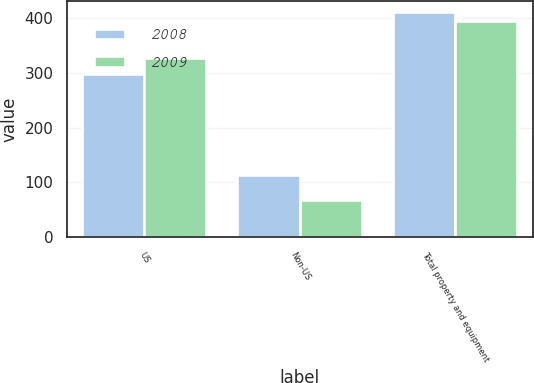<chart> <loc_0><loc_0><loc_500><loc_500><stacked_bar_chart><ecel><fcel>US<fcel>Non-US<fcel>Total property and equipment<nl><fcel>2008<fcel>298<fcel>113<fcel>411<nl><fcel>2009<fcel>327<fcel>68<fcel>395<nl></chart> 